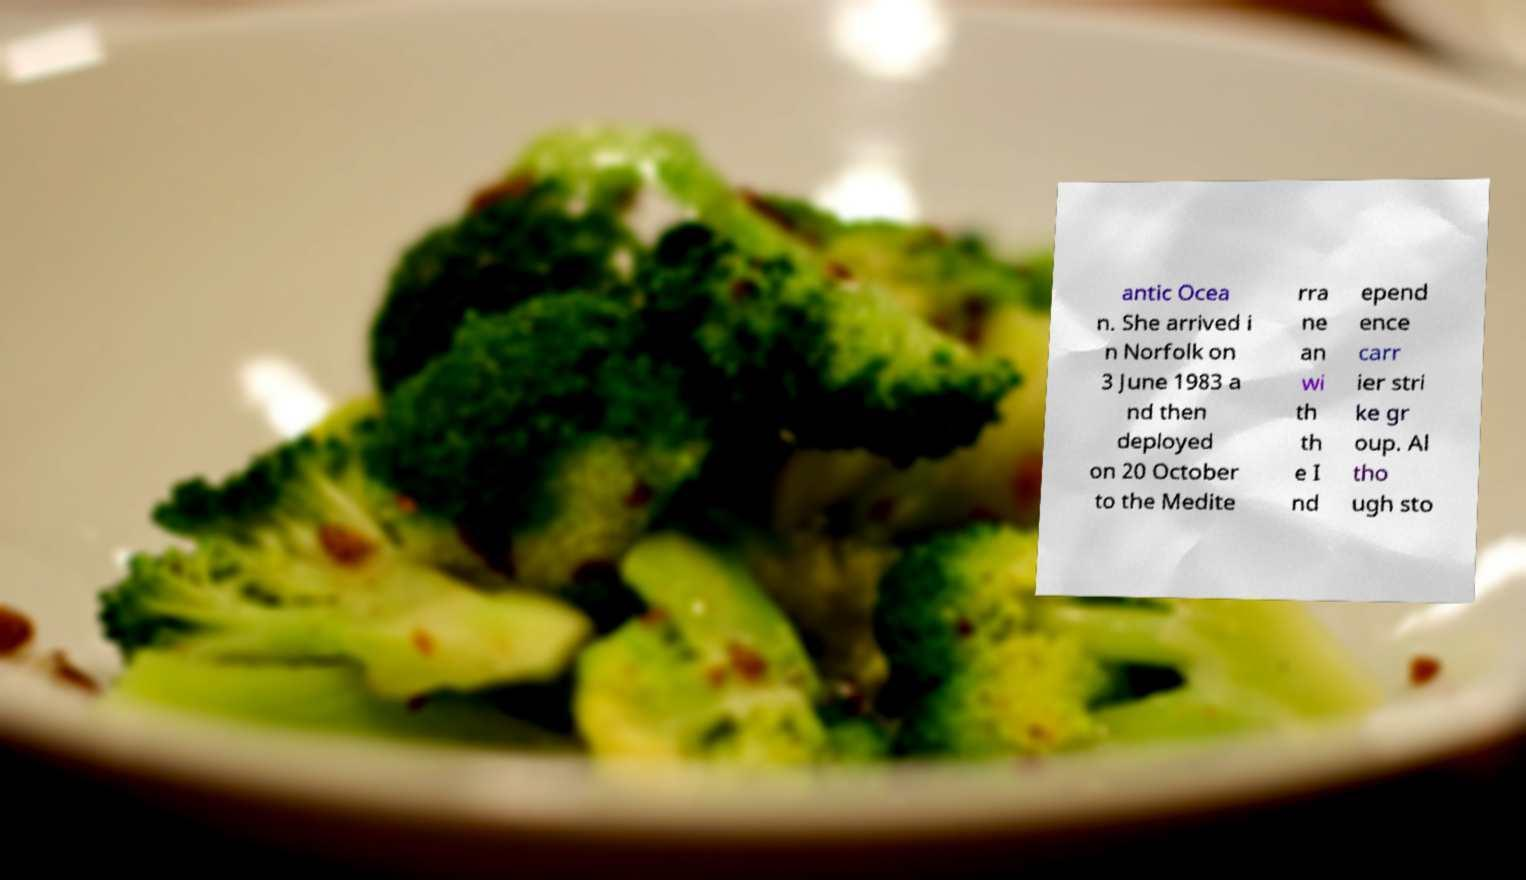Could you extract and type out the text from this image? antic Ocea n. She arrived i n Norfolk on 3 June 1983 a nd then deployed on 20 October to the Medite rra ne an wi th th e I nd epend ence carr ier stri ke gr oup. Al tho ugh sto 